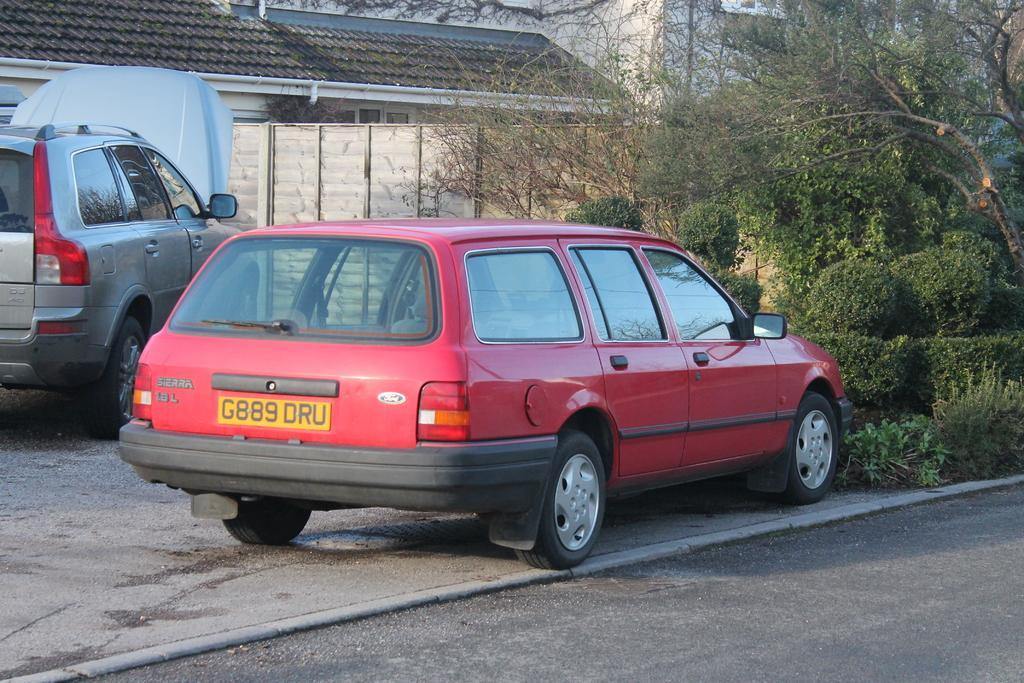In one or two sentences, can you explain what this image depicts? Here we can see two vehicles on the ground. In the background there are two houses,pipe on the wall,trees,plants,gate,wall and at the bottom we can see a road. 